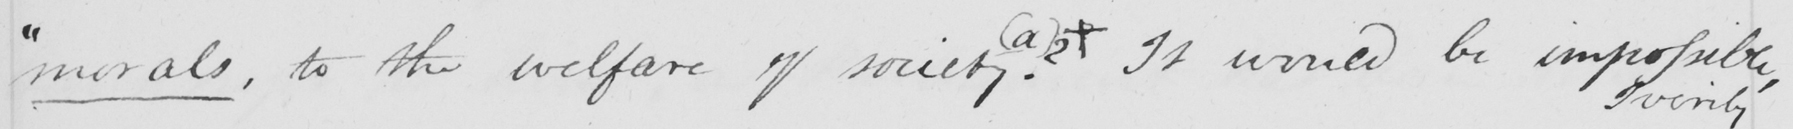What does this handwritten line say? " morals , to the welfare of society ?   ( a )  ?  +  It would be impossible , 